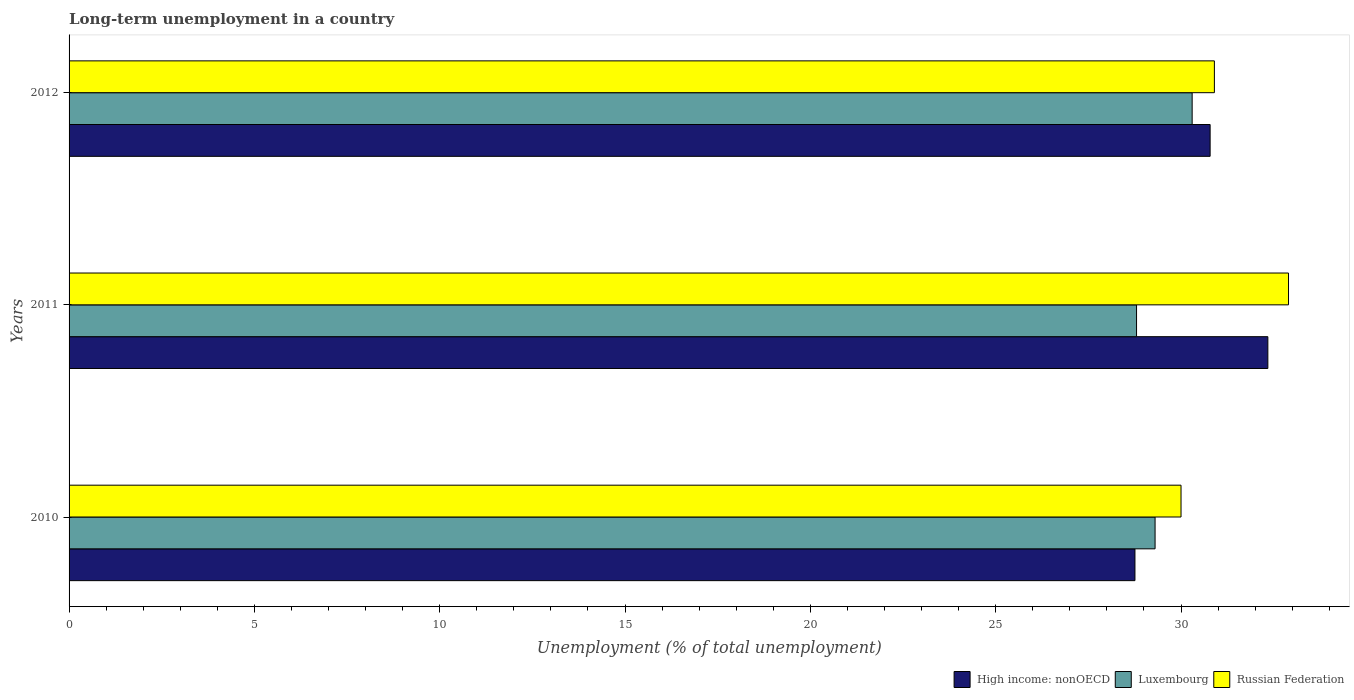How many groups of bars are there?
Provide a short and direct response. 3. Are the number of bars on each tick of the Y-axis equal?
Your answer should be very brief. Yes. In how many cases, is the number of bars for a given year not equal to the number of legend labels?
Offer a very short reply. 0. What is the percentage of long-term unemployed population in High income: nonOECD in 2010?
Offer a very short reply. 28.76. Across all years, what is the maximum percentage of long-term unemployed population in Russian Federation?
Offer a terse response. 32.9. Across all years, what is the minimum percentage of long-term unemployed population in High income: nonOECD?
Provide a succinct answer. 28.76. In which year was the percentage of long-term unemployed population in Russian Federation maximum?
Give a very brief answer. 2011. In which year was the percentage of long-term unemployed population in High income: nonOECD minimum?
Keep it short and to the point. 2010. What is the total percentage of long-term unemployed population in Russian Federation in the graph?
Provide a short and direct response. 93.8. What is the difference between the percentage of long-term unemployed population in Russian Federation in 2011 and that in 2012?
Keep it short and to the point. 2. What is the difference between the percentage of long-term unemployed population in Russian Federation in 2010 and the percentage of long-term unemployed population in High income: nonOECD in 2011?
Offer a terse response. -2.34. What is the average percentage of long-term unemployed population in High income: nonOECD per year?
Offer a very short reply. 30.63. In the year 2012, what is the difference between the percentage of long-term unemployed population in Luxembourg and percentage of long-term unemployed population in Russian Federation?
Your answer should be very brief. -0.6. In how many years, is the percentage of long-term unemployed population in Luxembourg greater than 19 %?
Your answer should be very brief. 3. What is the ratio of the percentage of long-term unemployed population in Russian Federation in 2010 to that in 2011?
Your response must be concise. 0.91. Is the percentage of long-term unemployed population in Luxembourg in 2011 less than that in 2012?
Provide a short and direct response. Yes. Is the difference between the percentage of long-term unemployed population in Luxembourg in 2010 and 2012 greater than the difference between the percentage of long-term unemployed population in Russian Federation in 2010 and 2012?
Your answer should be very brief. No. What is the difference between the highest and the second highest percentage of long-term unemployed population in Russian Federation?
Provide a succinct answer. 2. What is the difference between the highest and the lowest percentage of long-term unemployed population in Russian Federation?
Give a very brief answer. 2.9. What does the 3rd bar from the top in 2011 represents?
Keep it short and to the point. High income: nonOECD. What does the 1st bar from the bottom in 2011 represents?
Your response must be concise. High income: nonOECD. Is it the case that in every year, the sum of the percentage of long-term unemployed population in High income: nonOECD and percentage of long-term unemployed population in Russian Federation is greater than the percentage of long-term unemployed population in Luxembourg?
Offer a very short reply. Yes. How many bars are there?
Ensure brevity in your answer.  9. Does the graph contain any zero values?
Offer a terse response. No. Where does the legend appear in the graph?
Give a very brief answer. Bottom right. How many legend labels are there?
Ensure brevity in your answer.  3. What is the title of the graph?
Your answer should be very brief. Long-term unemployment in a country. What is the label or title of the X-axis?
Your answer should be compact. Unemployment (% of total unemployment). What is the Unemployment (% of total unemployment) in High income: nonOECD in 2010?
Provide a short and direct response. 28.76. What is the Unemployment (% of total unemployment) of Luxembourg in 2010?
Provide a succinct answer. 29.3. What is the Unemployment (% of total unemployment) of Russian Federation in 2010?
Keep it short and to the point. 30. What is the Unemployment (% of total unemployment) of High income: nonOECD in 2011?
Your answer should be compact. 32.34. What is the Unemployment (% of total unemployment) of Luxembourg in 2011?
Your answer should be compact. 28.8. What is the Unemployment (% of total unemployment) of Russian Federation in 2011?
Make the answer very short. 32.9. What is the Unemployment (% of total unemployment) of High income: nonOECD in 2012?
Keep it short and to the point. 30.78. What is the Unemployment (% of total unemployment) of Luxembourg in 2012?
Your answer should be very brief. 30.3. What is the Unemployment (% of total unemployment) in Russian Federation in 2012?
Offer a terse response. 30.9. Across all years, what is the maximum Unemployment (% of total unemployment) in High income: nonOECD?
Provide a short and direct response. 32.34. Across all years, what is the maximum Unemployment (% of total unemployment) in Luxembourg?
Your answer should be very brief. 30.3. Across all years, what is the maximum Unemployment (% of total unemployment) of Russian Federation?
Provide a succinct answer. 32.9. Across all years, what is the minimum Unemployment (% of total unemployment) in High income: nonOECD?
Keep it short and to the point. 28.76. Across all years, what is the minimum Unemployment (% of total unemployment) of Luxembourg?
Ensure brevity in your answer.  28.8. Across all years, what is the minimum Unemployment (% of total unemployment) of Russian Federation?
Your answer should be compact. 30. What is the total Unemployment (% of total unemployment) in High income: nonOECD in the graph?
Offer a terse response. 91.88. What is the total Unemployment (% of total unemployment) in Luxembourg in the graph?
Provide a short and direct response. 88.4. What is the total Unemployment (% of total unemployment) of Russian Federation in the graph?
Provide a short and direct response. 93.8. What is the difference between the Unemployment (% of total unemployment) of High income: nonOECD in 2010 and that in 2011?
Provide a succinct answer. -3.59. What is the difference between the Unemployment (% of total unemployment) of Luxembourg in 2010 and that in 2011?
Offer a terse response. 0.5. What is the difference between the Unemployment (% of total unemployment) of Russian Federation in 2010 and that in 2011?
Keep it short and to the point. -2.9. What is the difference between the Unemployment (% of total unemployment) of High income: nonOECD in 2010 and that in 2012?
Offer a terse response. -2.03. What is the difference between the Unemployment (% of total unemployment) of Luxembourg in 2010 and that in 2012?
Make the answer very short. -1. What is the difference between the Unemployment (% of total unemployment) of High income: nonOECD in 2011 and that in 2012?
Provide a succinct answer. 1.56. What is the difference between the Unemployment (% of total unemployment) of Luxembourg in 2011 and that in 2012?
Ensure brevity in your answer.  -1.5. What is the difference between the Unemployment (% of total unemployment) in Russian Federation in 2011 and that in 2012?
Offer a very short reply. 2. What is the difference between the Unemployment (% of total unemployment) of High income: nonOECD in 2010 and the Unemployment (% of total unemployment) of Luxembourg in 2011?
Your response must be concise. -0.04. What is the difference between the Unemployment (% of total unemployment) of High income: nonOECD in 2010 and the Unemployment (% of total unemployment) of Russian Federation in 2011?
Your response must be concise. -4.14. What is the difference between the Unemployment (% of total unemployment) in High income: nonOECD in 2010 and the Unemployment (% of total unemployment) in Luxembourg in 2012?
Ensure brevity in your answer.  -1.54. What is the difference between the Unemployment (% of total unemployment) in High income: nonOECD in 2010 and the Unemployment (% of total unemployment) in Russian Federation in 2012?
Give a very brief answer. -2.14. What is the difference between the Unemployment (% of total unemployment) in High income: nonOECD in 2011 and the Unemployment (% of total unemployment) in Luxembourg in 2012?
Offer a terse response. 2.04. What is the difference between the Unemployment (% of total unemployment) of High income: nonOECD in 2011 and the Unemployment (% of total unemployment) of Russian Federation in 2012?
Give a very brief answer. 1.44. What is the difference between the Unemployment (% of total unemployment) of Luxembourg in 2011 and the Unemployment (% of total unemployment) of Russian Federation in 2012?
Provide a short and direct response. -2.1. What is the average Unemployment (% of total unemployment) in High income: nonOECD per year?
Provide a succinct answer. 30.63. What is the average Unemployment (% of total unemployment) of Luxembourg per year?
Provide a short and direct response. 29.47. What is the average Unemployment (% of total unemployment) of Russian Federation per year?
Keep it short and to the point. 31.27. In the year 2010, what is the difference between the Unemployment (% of total unemployment) of High income: nonOECD and Unemployment (% of total unemployment) of Luxembourg?
Keep it short and to the point. -0.54. In the year 2010, what is the difference between the Unemployment (% of total unemployment) in High income: nonOECD and Unemployment (% of total unemployment) in Russian Federation?
Give a very brief answer. -1.24. In the year 2010, what is the difference between the Unemployment (% of total unemployment) in Luxembourg and Unemployment (% of total unemployment) in Russian Federation?
Give a very brief answer. -0.7. In the year 2011, what is the difference between the Unemployment (% of total unemployment) in High income: nonOECD and Unemployment (% of total unemployment) in Luxembourg?
Your response must be concise. 3.54. In the year 2011, what is the difference between the Unemployment (% of total unemployment) of High income: nonOECD and Unemployment (% of total unemployment) of Russian Federation?
Offer a very short reply. -0.56. In the year 2012, what is the difference between the Unemployment (% of total unemployment) of High income: nonOECD and Unemployment (% of total unemployment) of Luxembourg?
Your answer should be compact. 0.48. In the year 2012, what is the difference between the Unemployment (% of total unemployment) in High income: nonOECD and Unemployment (% of total unemployment) in Russian Federation?
Offer a very short reply. -0.12. What is the ratio of the Unemployment (% of total unemployment) of High income: nonOECD in 2010 to that in 2011?
Offer a terse response. 0.89. What is the ratio of the Unemployment (% of total unemployment) in Luxembourg in 2010 to that in 2011?
Make the answer very short. 1.02. What is the ratio of the Unemployment (% of total unemployment) of Russian Federation in 2010 to that in 2011?
Offer a terse response. 0.91. What is the ratio of the Unemployment (% of total unemployment) of High income: nonOECD in 2010 to that in 2012?
Give a very brief answer. 0.93. What is the ratio of the Unemployment (% of total unemployment) in Luxembourg in 2010 to that in 2012?
Offer a terse response. 0.97. What is the ratio of the Unemployment (% of total unemployment) in Russian Federation in 2010 to that in 2012?
Offer a very short reply. 0.97. What is the ratio of the Unemployment (% of total unemployment) of High income: nonOECD in 2011 to that in 2012?
Give a very brief answer. 1.05. What is the ratio of the Unemployment (% of total unemployment) of Luxembourg in 2011 to that in 2012?
Your response must be concise. 0.95. What is the ratio of the Unemployment (% of total unemployment) of Russian Federation in 2011 to that in 2012?
Provide a succinct answer. 1.06. What is the difference between the highest and the second highest Unemployment (% of total unemployment) in High income: nonOECD?
Provide a succinct answer. 1.56. What is the difference between the highest and the second highest Unemployment (% of total unemployment) of Luxembourg?
Your answer should be very brief. 1. What is the difference between the highest and the second highest Unemployment (% of total unemployment) in Russian Federation?
Keep it short and to the point. 2. What is the difference between the highest and the lowest Unemployment (% of total unemployment) of High income: nonOECD?
Your answer should be very brief. 3.59. What is the difference between the highest and the lowest Unemployment (% of total unemployment) in Luxembourg?
Make the answer very short. 1.5. What is the difference between the highest and the lowest Unemployment (% of total unemployment) in Russian Federation?
Your response must be concise. 2.9. 